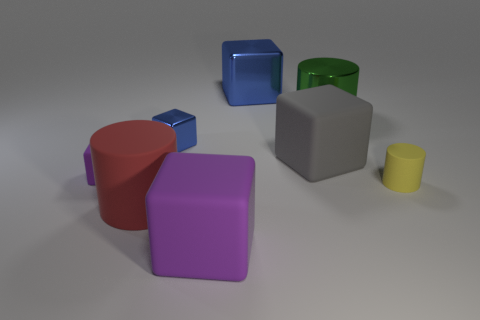Subtract all gray blocks. How many blocks are left? 4 Subtract all large blue metallic blocks. How many blocks are left? 4 Subtract all green blocks. Subtract all gray cylinders. How many blocks are left? 5 Add 1 red rubber cylinders. How many objects exist? 9 Subtract all cylinders. How many objects are left? 5 Add 3 big purple cubes. How many big purple cubes exist? 4 Subtract 0 brown cylinders. How many objects are left? 8 Subtract all large rubber objects. Subtract all big metallic cubes. How many objects are left? 4 Add 6 small yellow things. How many small yellow things are left? 7 